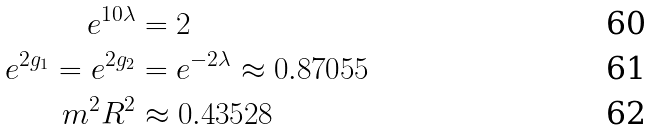<formula> <loc_0><loc_0><loc_500><loc_500>e ^ { 1 0 \lambda } & = 2 \\ e ^ { 2 g _ { 1 } } = e ^ { 2 g _ { 2 } } & = e ^ { - 2 \lambda } \approx 0 . 8 7 0 5 5 \\ m ^ { 2 } R ^ { 2 } & \approx 0 . 4 3 5 2 8</formula> 